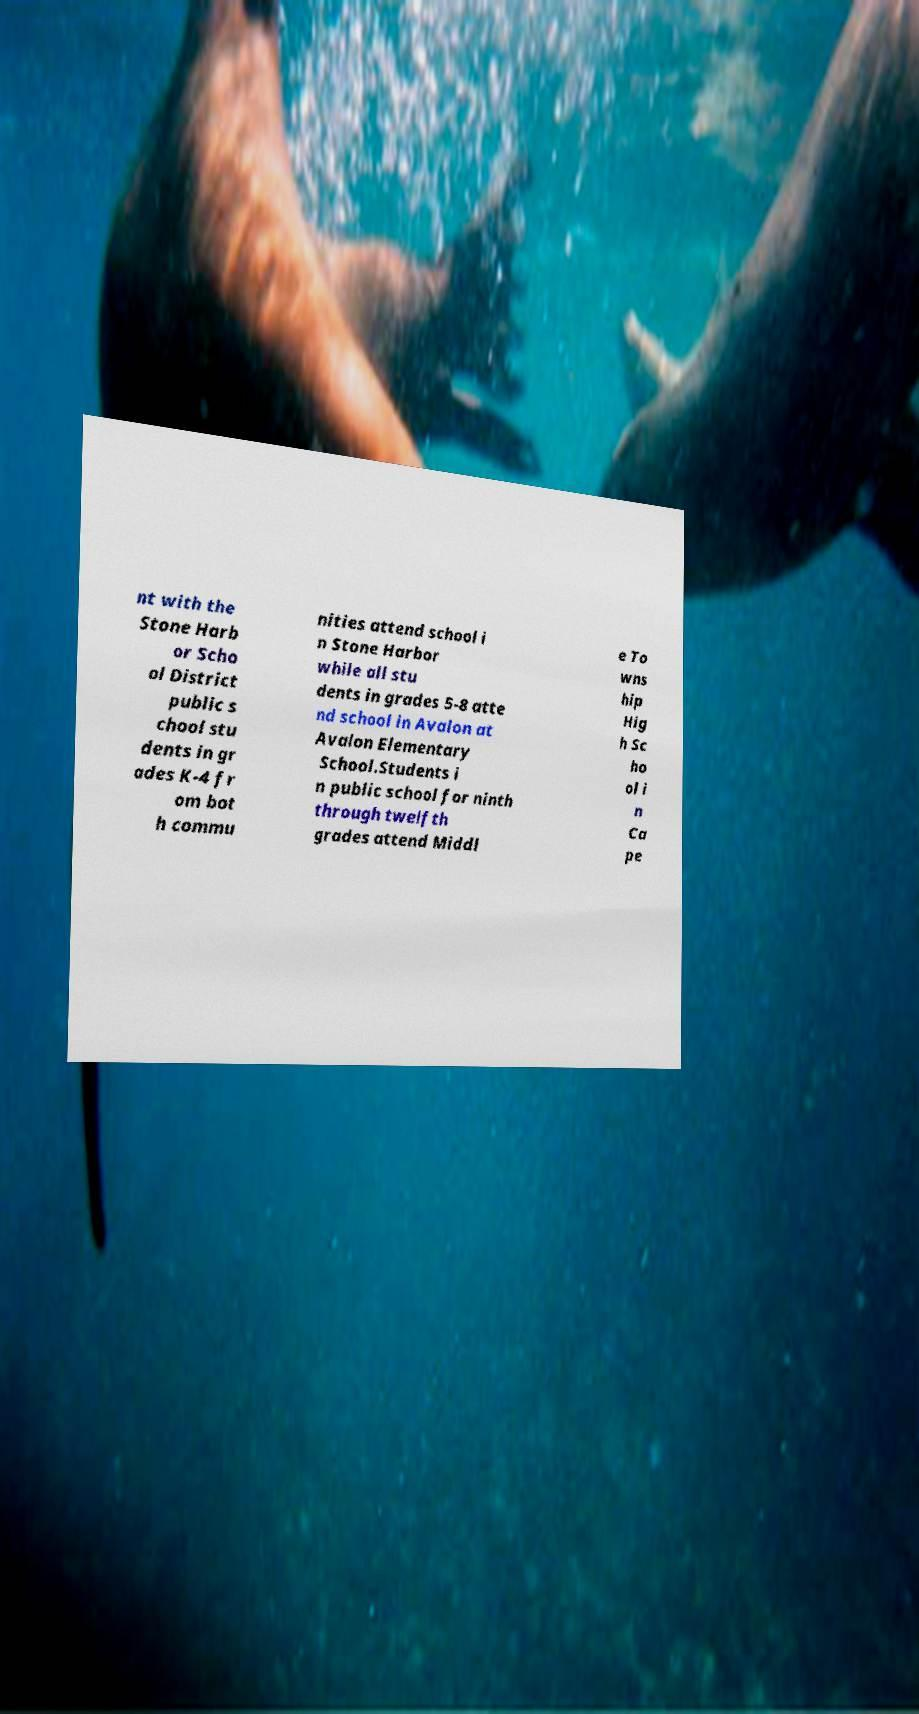Can you accurately transcribe the text from the provided image for me? nt with the Stone Harb or Scho ol District public s chool stu dents in gr ades K-4 fr om bot h commu nities attend school i n Stone Harbor while all stu dents in grades 5-8 atte nd school in Avalon at Avalon Elementary School.Students i n public school for ninth through twelfth grades attend Middl e To wns hip Hig h Sc ho ol i n Ca pe 